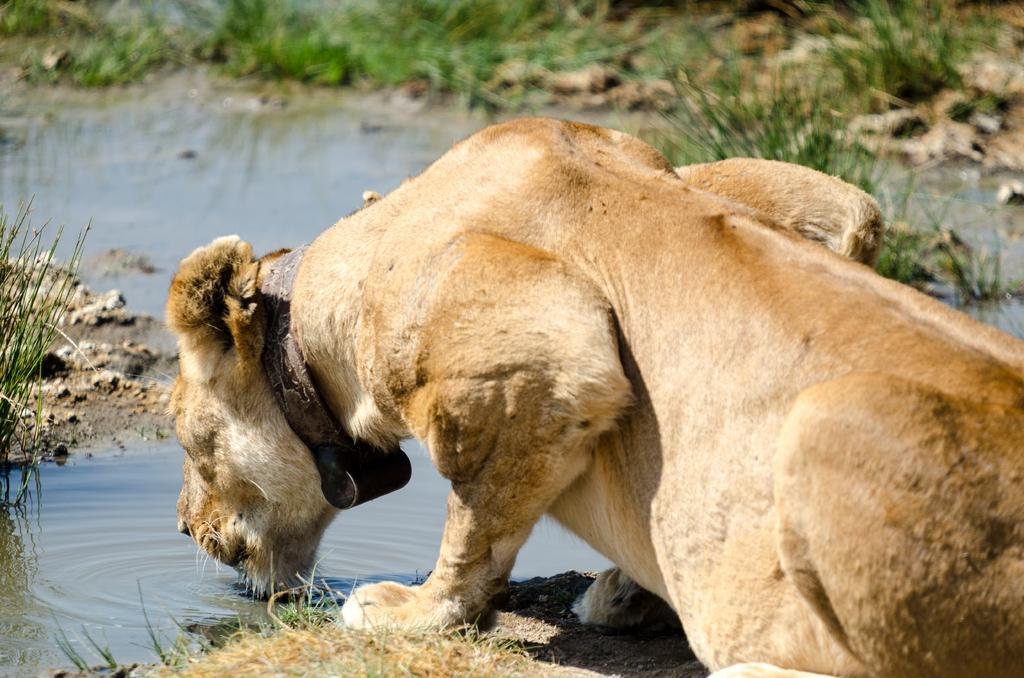What animal is present in the image? There is a lion in the image. What is the lion doing in the image? The lion is drinking water. What type of vegetation can be seen in the background of the image? There is grass in the background of the image. What type of terrain is visible at the bottom of the image? There is sand at the bottom of the image. What type of sweater is the lion wearing in the image? There is no sweater present in the image; the lion is not wearing any clothing. 